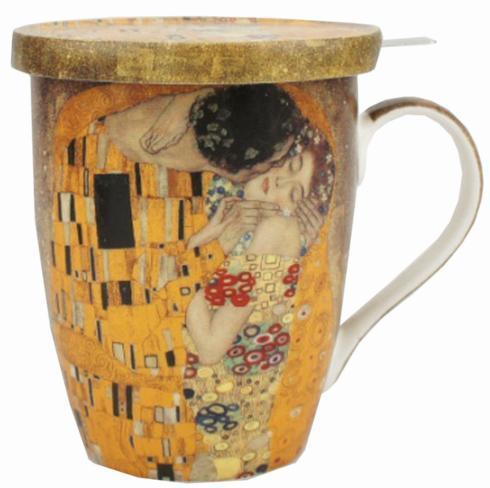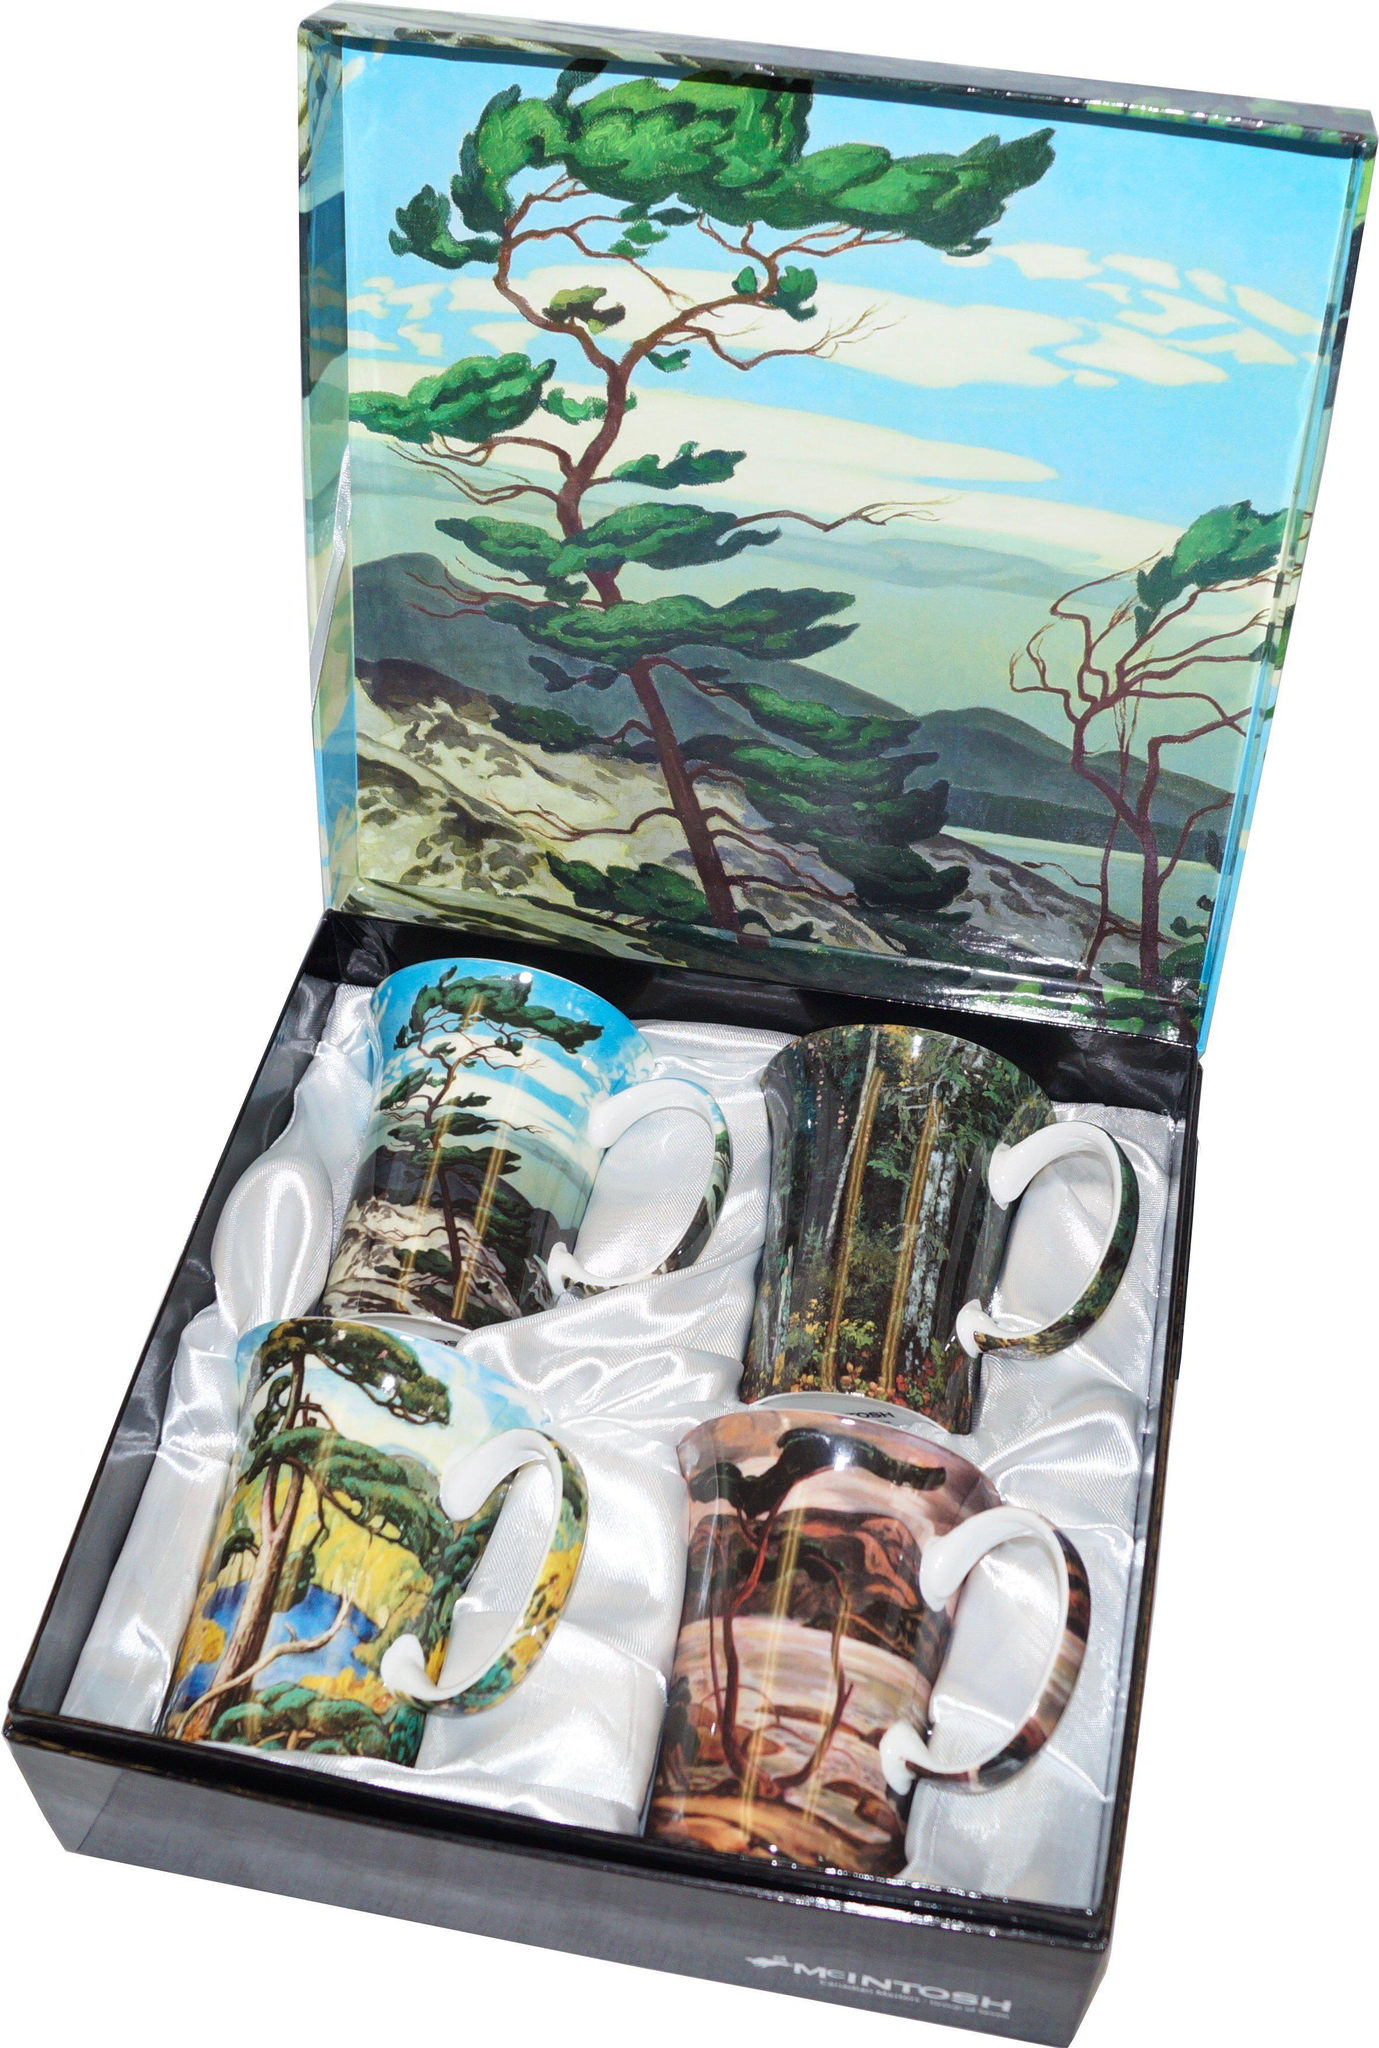The first image is the image on the left, the second image is the image on the right. Analyze the images presented: Is the assertion "Four mugs sit in a case while four sit outside the case in the image on the right." valid? Answer yes or no. No. 